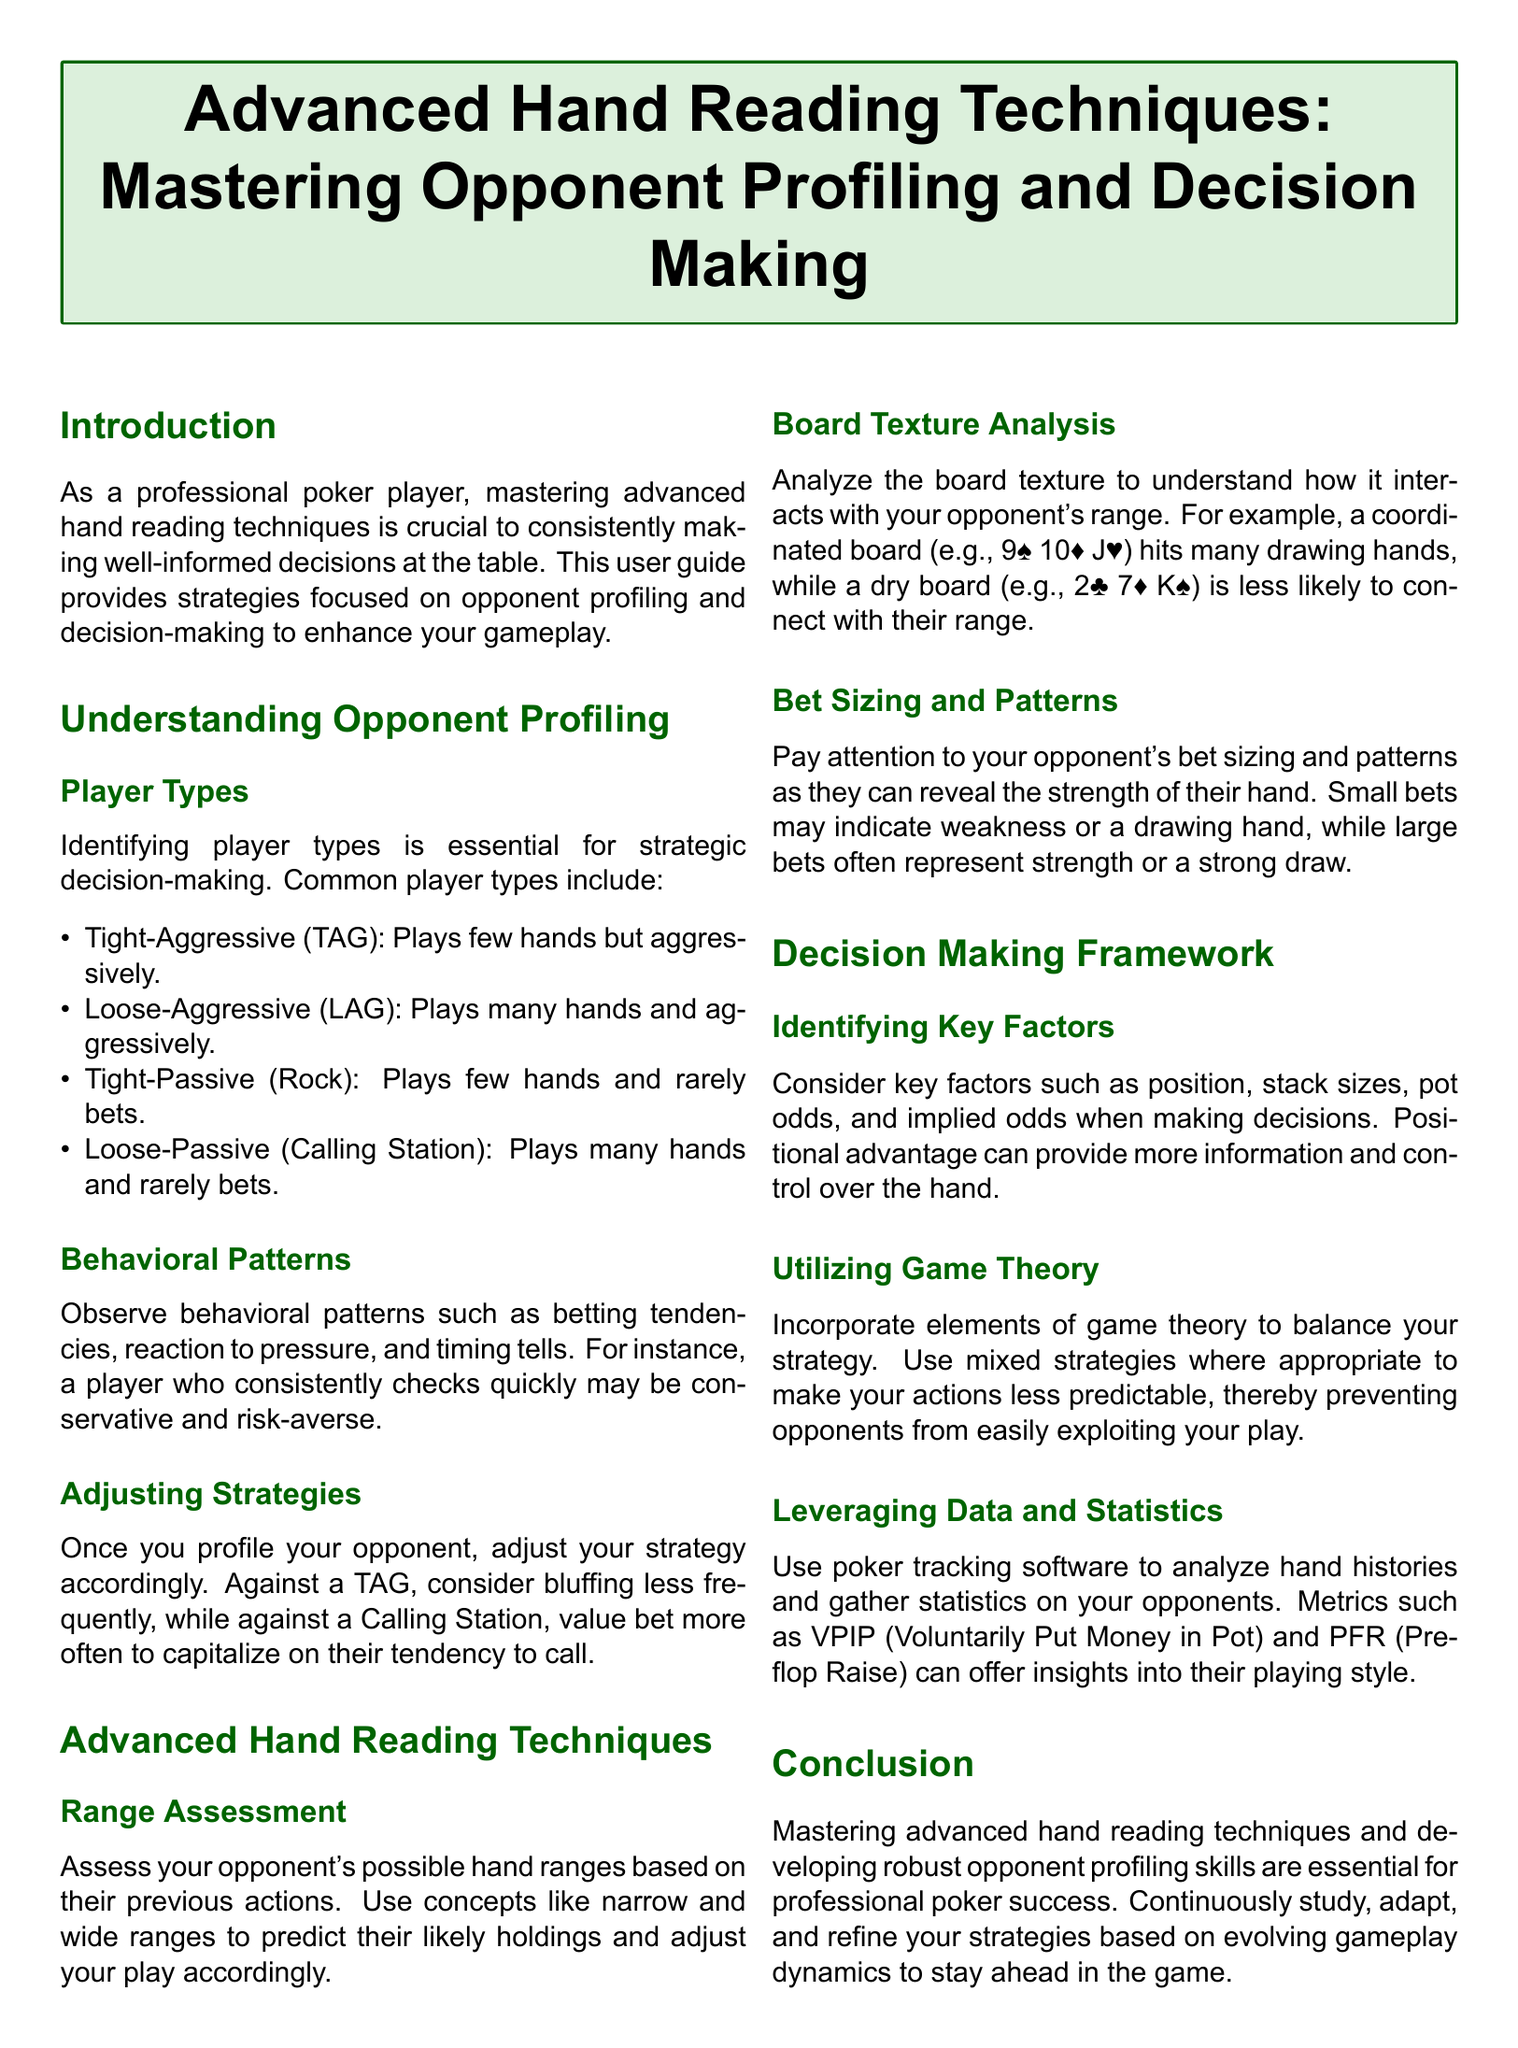What are the four common player types? The section on Player Types lists the four common player types, which are Tight-Aggressive (TAG), Loose-Aggressive (LAG), Tight-Passive (Rock), and Loose-Passive (Calling Station).
Answer: Tight-Aggressive, Loose-Aggressive, Tight-Passive, Loose-Passive What does TAG stand for? TAG refers to the Tight-Aggressive player type, which is defined in the document.
Answer: Tight-Aggressive What type of board texture interacts with many drawing hands? The document notes that a coordinated board (like 9♠ 10♦ J♥) hits many drawing hands.
Answer: Coordinated board What should you consider when making decisions? The section on Identifying Key Factors lists position, stack sizes, pot odds, and implied odds as considerations.
Answer: Position, stack sizes, pot odds, implied odds What is VPIP an acronym for? The document explains that VPIP stands for Voluntarily Put Money in Pot, which is a metric discussed.
Answer: Voluntarily Put Money in Pot Which strategy may help make your actions less predictable? The document mentions using mixed strategies as a means to balance your strategy and reduce predictability.
Answer: Mixed strategies How should you adjust your strategy against a Calling Station? The guide instructs players to value bet more often when facing a Calling Station.
Answer: Value bet more often What will the analysis of opponents reveal? The document states that analyzing hand histories and gathering statistics on opponents provides insights into their playing style.
Answer: Insights into their playing style 